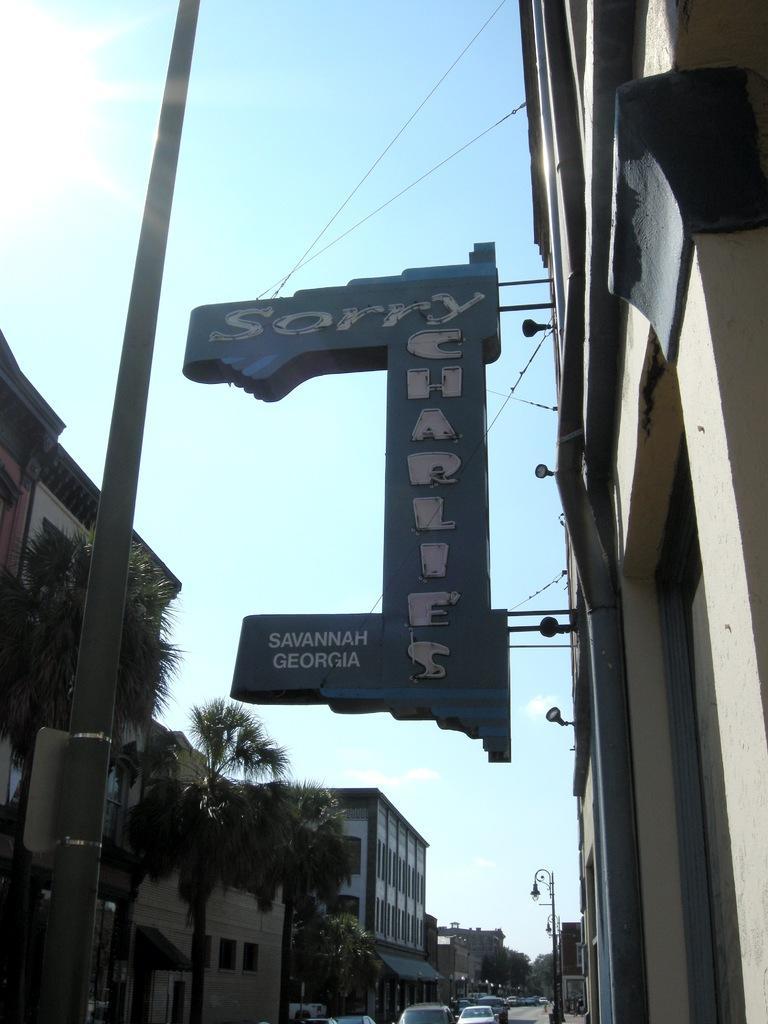Can you describe this image briefly? In this image I can see a building and a board attached to the building. I can see a metal pole, few trees, few buildings, few vehicles on the road and in the background I can see the sky. 